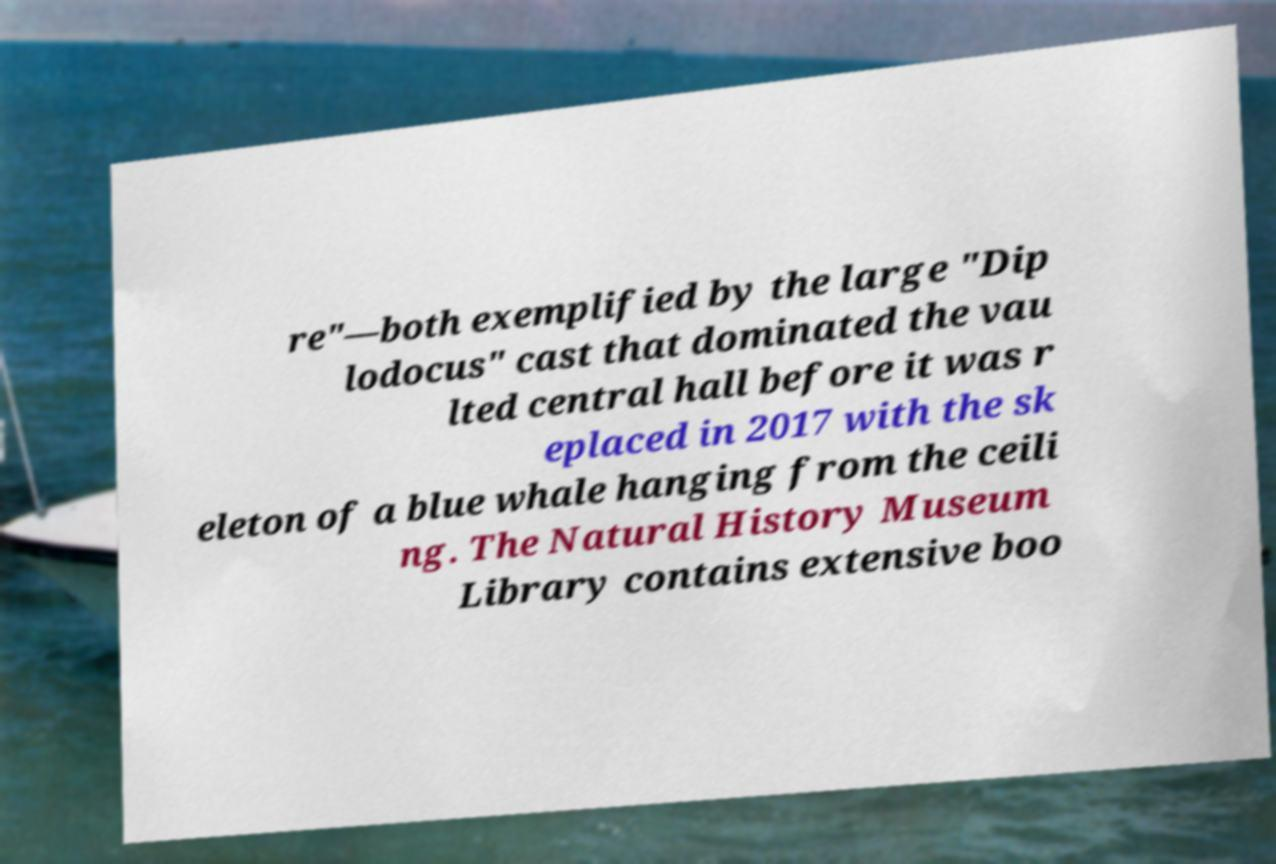Could you extract and type out the text from this image? re"—both exemplified by the large "Dip lodocus" cast that dominated the vau lted central hall before it was r eplaced in 2017 with the sk eleton of a blue whale hanging from the ceili ng. The Natural History Museum Library contains extensive boo 